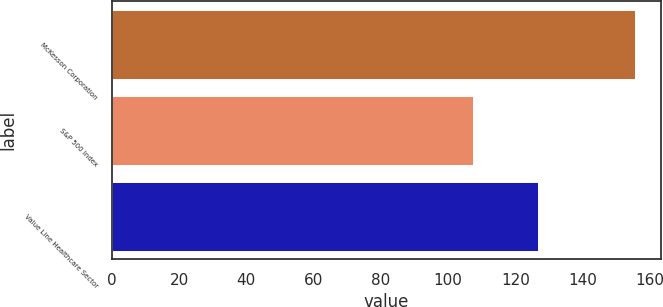Convert chart. <chart><loc_0><loc_0><loc_500><loc_500><bar_chart><fcel>McKesson Corporation<fcel>S&P 500 Index<fcel>Value Line Healthcare Sector<nl><fcel>155.58<fcel>107.24<fcel>126.6<nl></chart> 